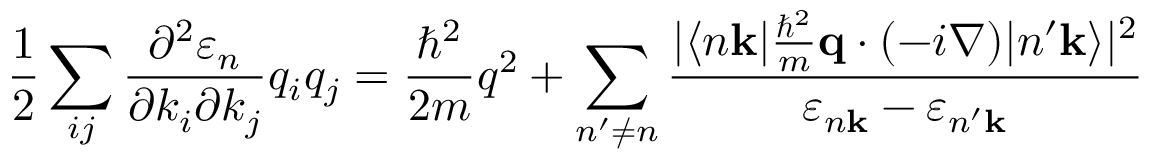Convert formula to latex. <formula><loc_0><loc_0><loc_500><loc_500>{ \frac { 1 } { 2 } } \sum _ { i j } { \frac { \partial ^ { 2 } \varepsilon _ { n } } { \partial k _ { i } \partial k _ { j } } } q _ { i } q _ { j } = { \frac { \hbar { ^ } { 2 } } { 2 m } } q ^ { 2 } + \sum _ { n ^ { \prime } \neq n } { \frac { | \langle n k | { \frac { \hbar { ^ } { 2 } } { m } } q \cdot ( - i \nabla ) | n ^ { \prime } k \rangle | ^ { 2 } } { \varepsilon _ { n k } - \varepsilon _ { n ^ { \prime } k } } }</formula> 